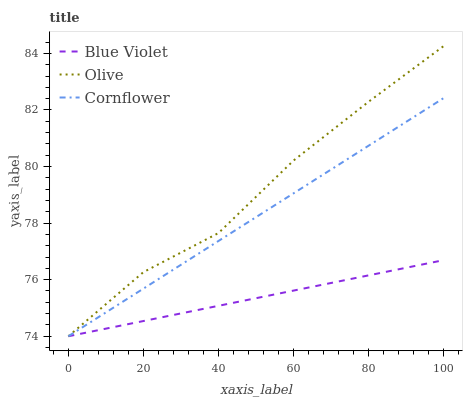Does Blue Violet have the minimum area under the curve?
Answer yes or no. Yes. Does Olive have the maximum area under the curve?
Answer yes or no. Yes. Does Cornflower have the minimum area under the curve?
Answer yes or no. No. Does Cornflower have the maximum area under the curve?
Answer yes or no. No. Is Cornflower the smoothest?
Answer yes or no. Yes. Is Olive the roughest?
Answer yes or no. Yes. Is Blue Violet the smoothest?
Answer yes or no. No. Is Blue Violet the roughest?
Answer yes or no. No. Does Olive have the highest value?
Answer yes or no. Yes. Does Cornflower have the highest value?
Answer yes or no. No. Does Olive intersect Blue Violet?
Answer yes or no. Yes. Is Olive less than Blue Violet?
Answer yes or no. No. Is Olive greater than Blue Violet?
Answer yes or no. No. 